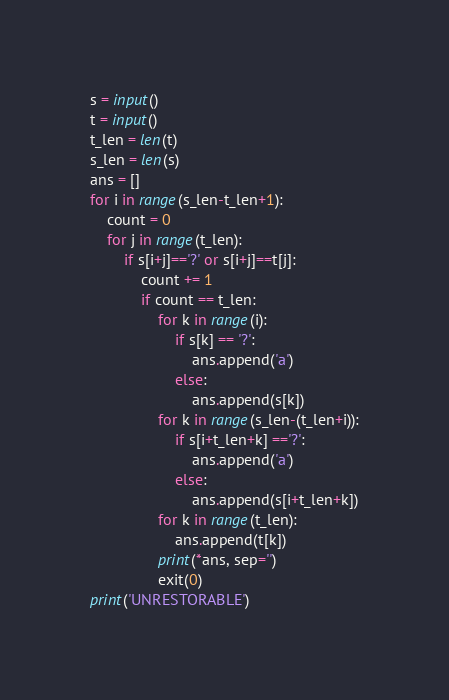Convert code to text. <code><loc_0><loc_0><loc_500><loc_500><_Python_>s = input()
t = input()
t_len = len(t)
s_len = len(s)
ans = []
for i in range(s_len-t_len+1):
    count = 0
    for j in range(t_len):
        if s[i+j]=='?' or s[i+j]==t[j]:
            count += 1
            if count == t_len:
                for k in range(i):
                    if s[k] == '?':
                        ans.append('a')
                    else:
                        ans.append(s[k])
                for k in range(s_len-(t_len+i)):
                    if s[i+t_len+k] =='?':
                        ans.append('a')
                    else:
                        ans.append(s[i+t_len+k])
                for k in range(t_len):
                    ans.append(t[k])
                print(*ans, sep='')
                exit(0)
print('UNRESTORABLE')</code> 